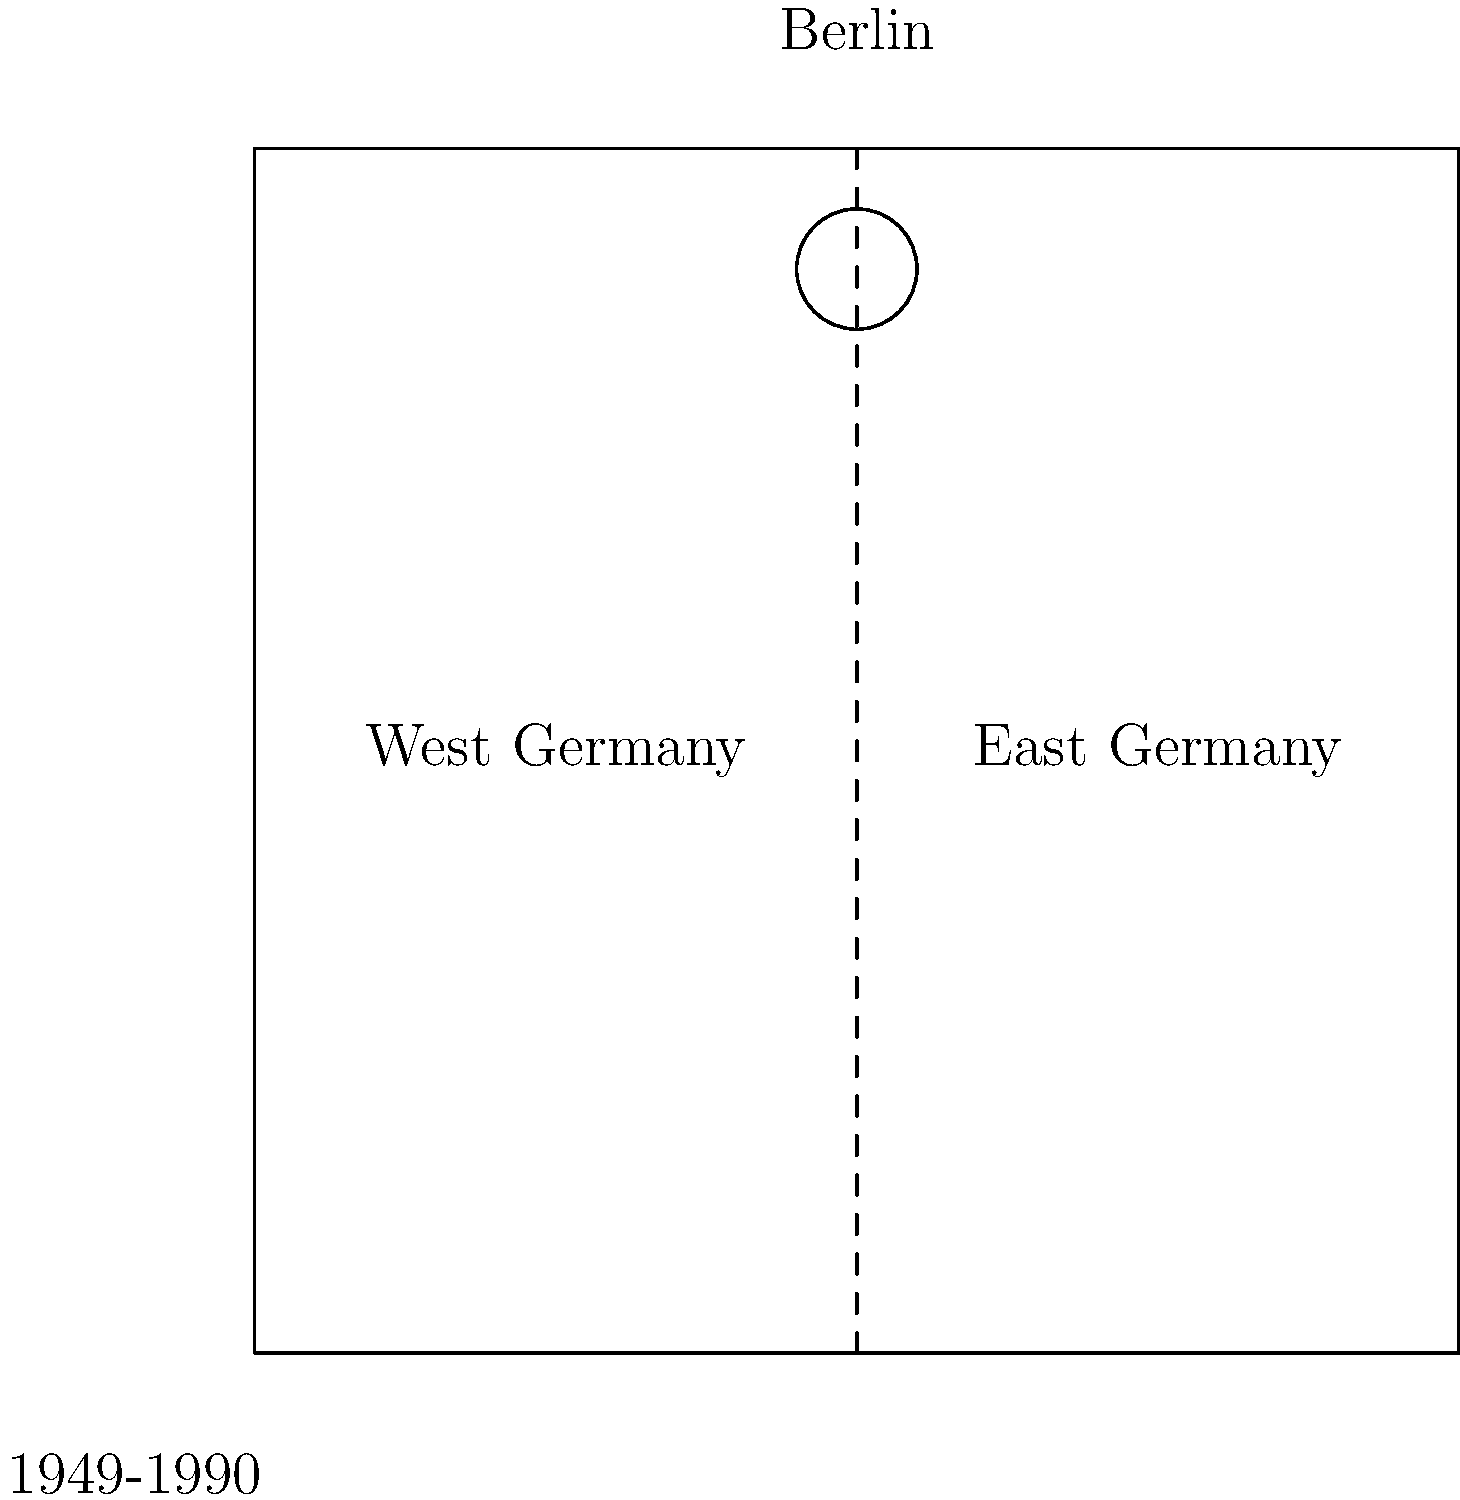Based on the diagram representing the division of Germany during the Cold War, which city served as a focal point of tensions and was itself divided between East and West? To answer this question, we need to analyze the diagram and understand the historical context of Germany during the Cold War:

1. The diagram shows Germany divided into two parts: West Germany on the left and East Germany on the right.

2. This division represents the post-World War II split of Germany into the Federal Republic of Germany (West) and the German Democratic Republic (East).

3. The dashed line in the middle represents the border between East and West Germany, known as the Inner German Border.

4. At the top of the diagram, slightly above the border, there is a circle labeled "Berlin."

5. Berlin's position is significant because:
   a) It is located on the border between East and West Germany.
   b) It is represented as a separate entity from the rest of the divided Germany.

6. Historically, Berlin was indeed divided into East and West sectors, despite being geographically located within East Germany.

7. Berlin became a symbol of the Cold War, with events such as the Berlin Blockade (1948-1949) and the construction of the Berlin Wall (1961) highlighting its importance.

Therefore, the city that served as a focal point of tensions and was itself divided between East and West during the Cold War period was Berlin.
Answer: Berlin 